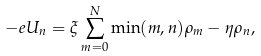Convert formula to latex. <formula><loc_0><loc_0><loc_500><loc_500>- e U _ { n } = \xi \sum _ { m = 0 } ^ { N } \min ( m , n ) \rho _ { m } - \eta \rho _ { n } ,</formula> 